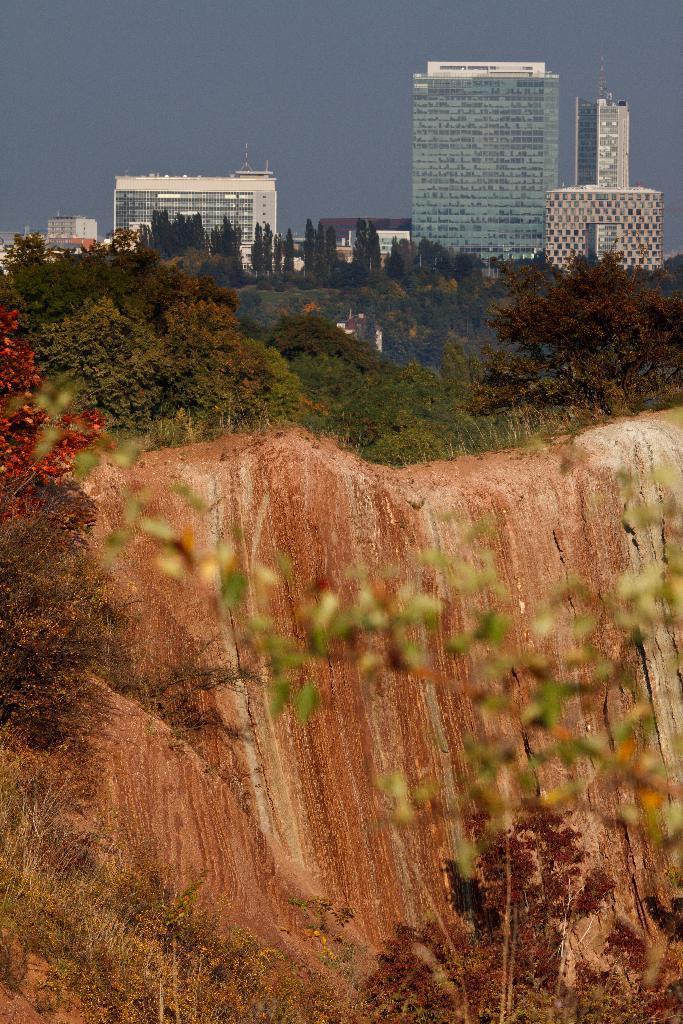Can you describe this image briefly? In this picture we can see few trees, rocks and buildings. 